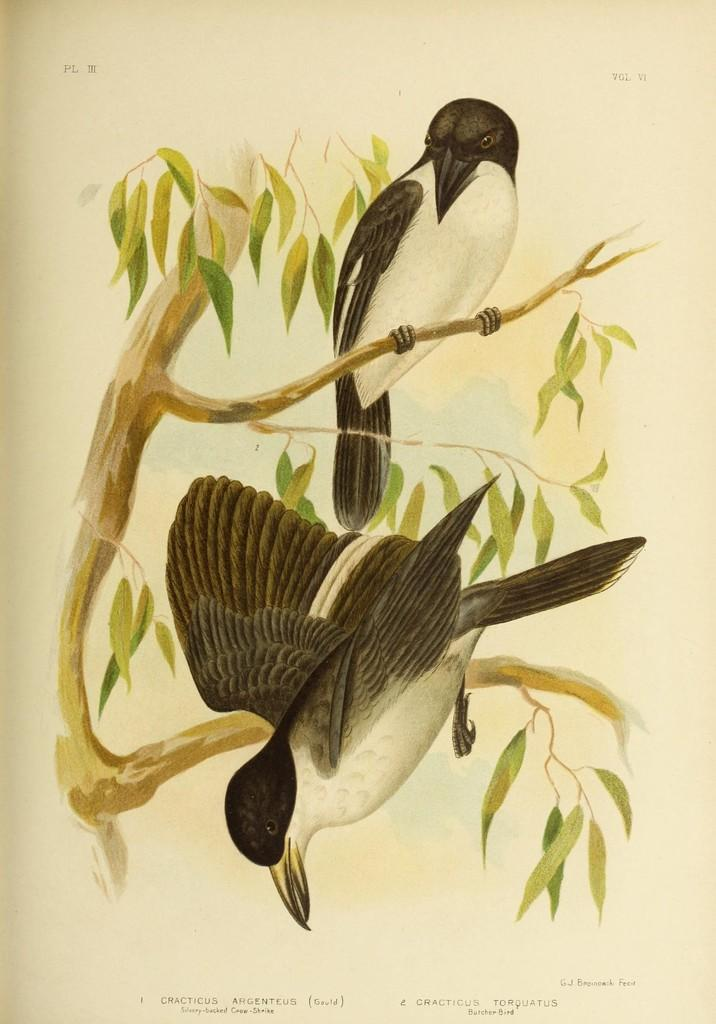What is depicted in the image? There are pictures of two birds in the image. Where are the birds located? The birds are on the branch of a tree. What can be seen in the background of the image? There is a group of leaves and some text visible in the background. How many bikes are parked near the birds in the image? There are no bikes present in the image. What type of event is taking place in the image? There is no event depicted in the image; it simply shows two birds on a tree branch. 